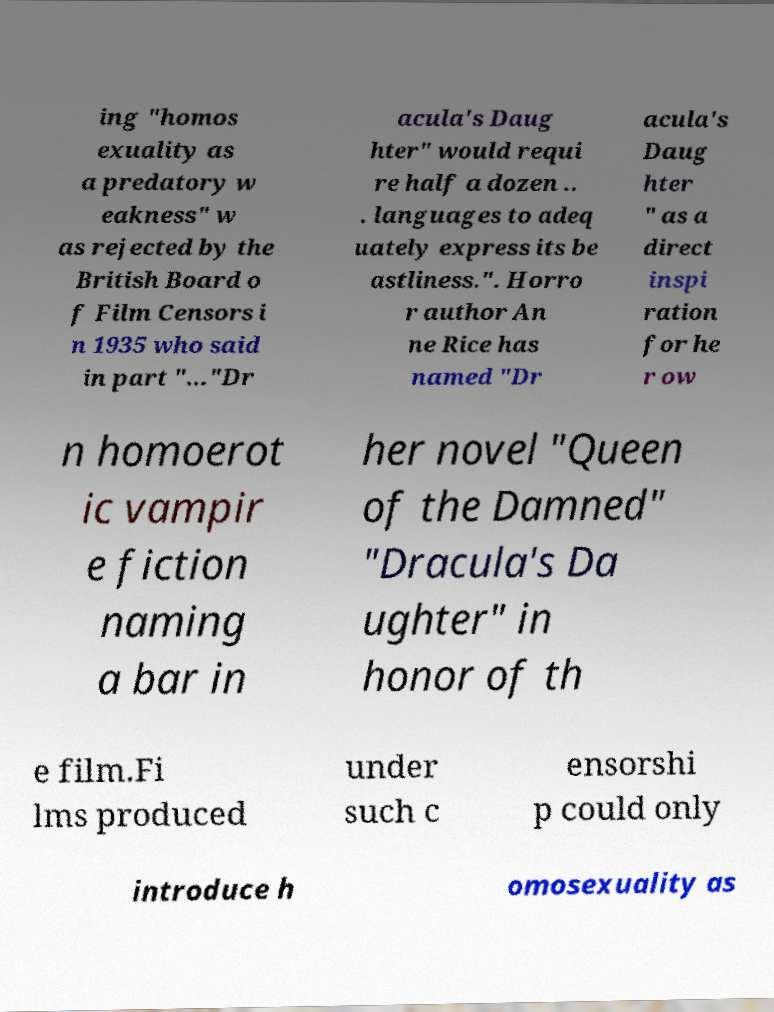There's text embedded in this image that I need extracted. Can you transcribe it verbatim? ing "homos exuality as a predatory w eakness" w as rejected by the British Board o f Film Censors i n 1935 who said in part "..."Dr acula's Daug hter" would requi re half a dozen .. . languages to adeq uately express its be astliness.". Horro r author An ne Rice has named "Dr acula's Daug hter " as a direct inspi ration for he r ow n homoerot ic vampir e fiction naming a bar in her novel "Queen of the Damned" "Dracula's Da ughter" in honor of th e film.Fi lms produced under such c ensorshi p could only introduce h omosexuality as 